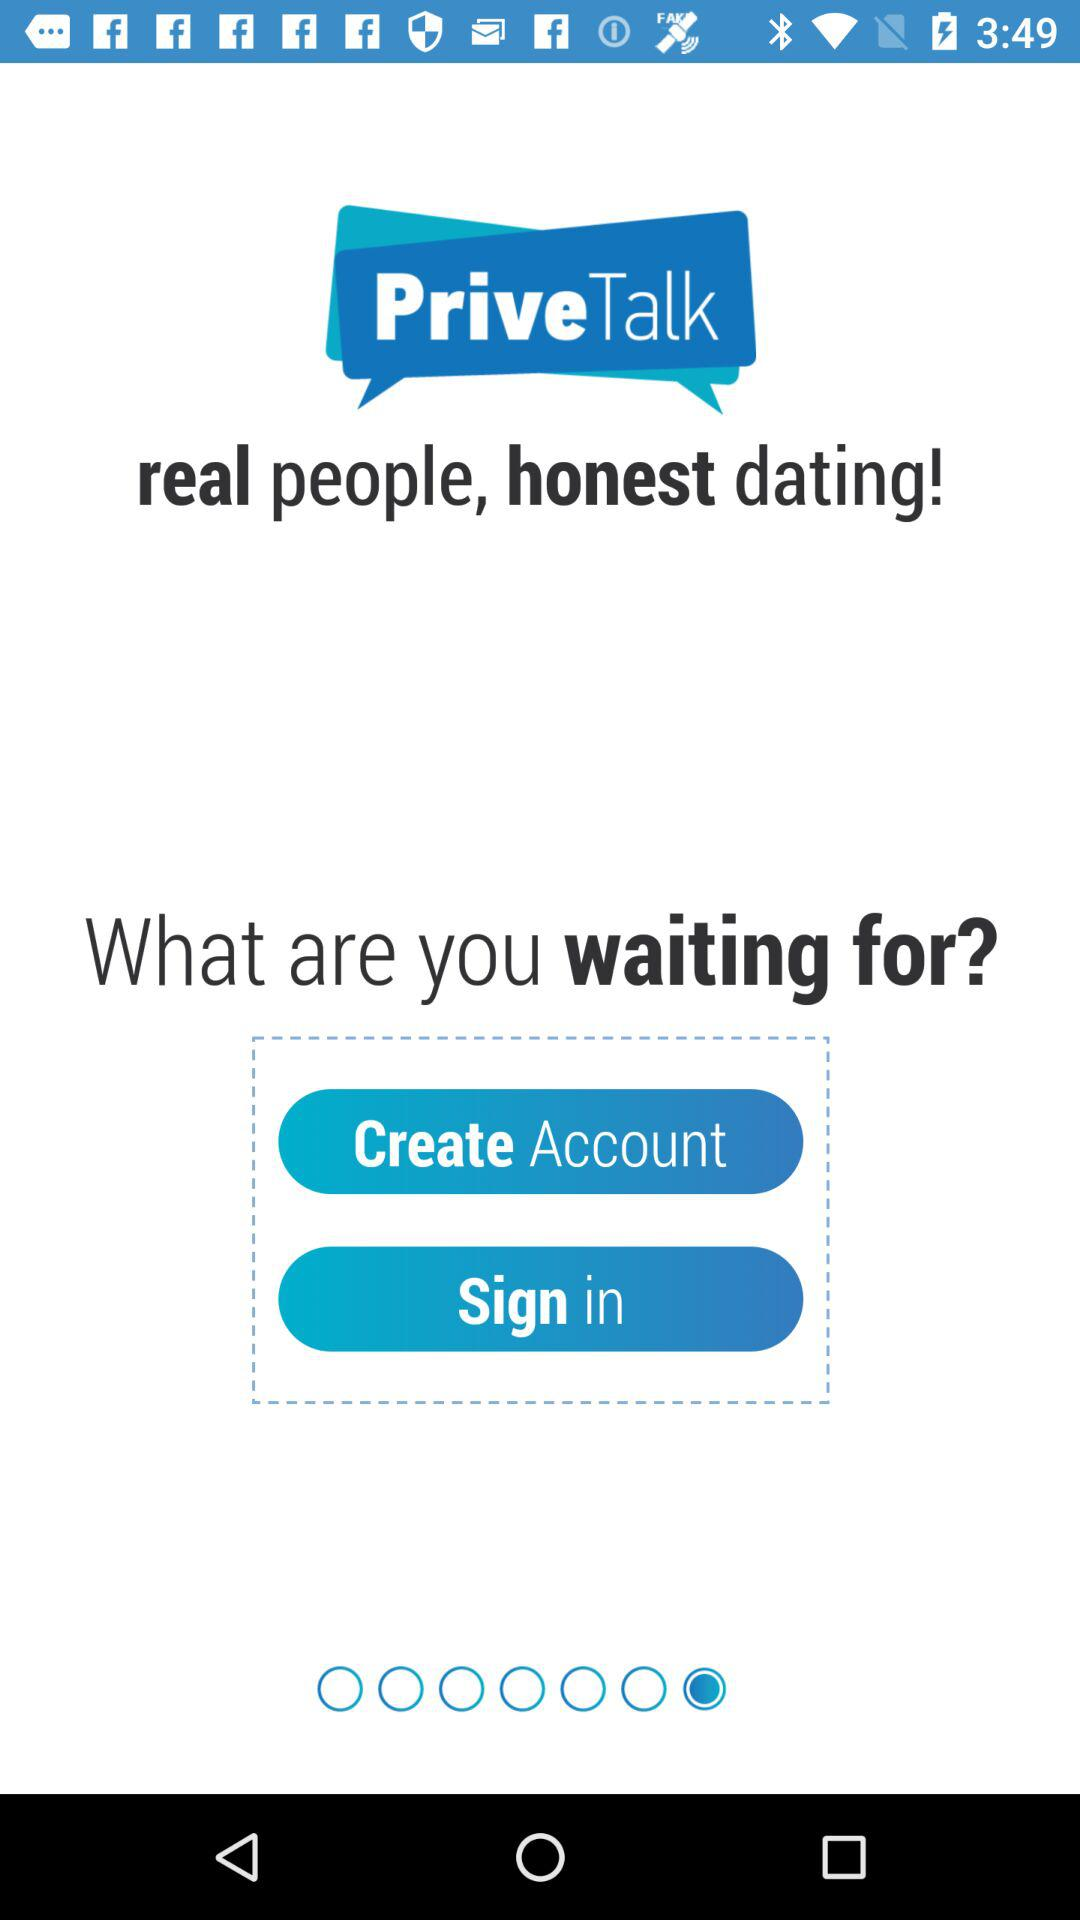What's the application name? The application name is "PriveTalk". 